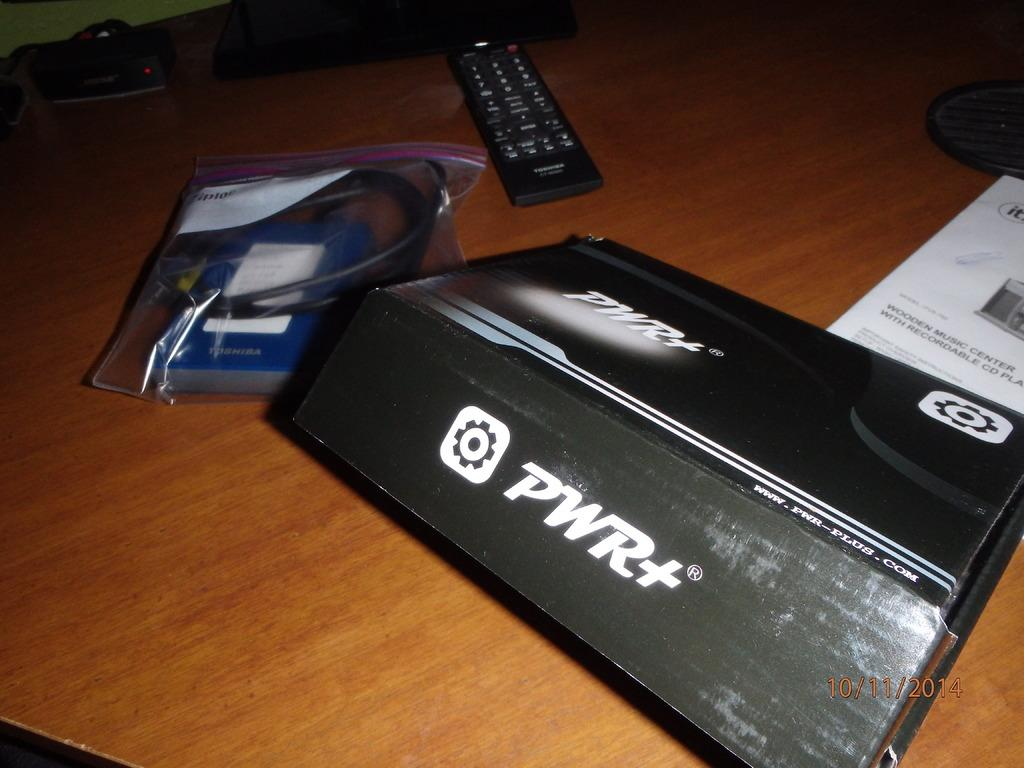<image>
Provide a brief description of the given image. A TV remote, a bag and a device by PVR on a wooden table. 